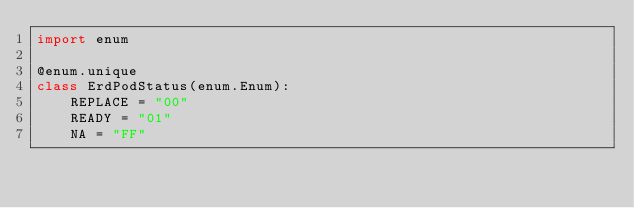Convert code to text. <code><loc_0><loc_0><loc_500><loc_500><_Python_>import enum

@enum.unique
class ErdPodStatus(enum.Enum):
    REPLACE = "00"
    READY = "01"
    NA = "FF"
</code> 